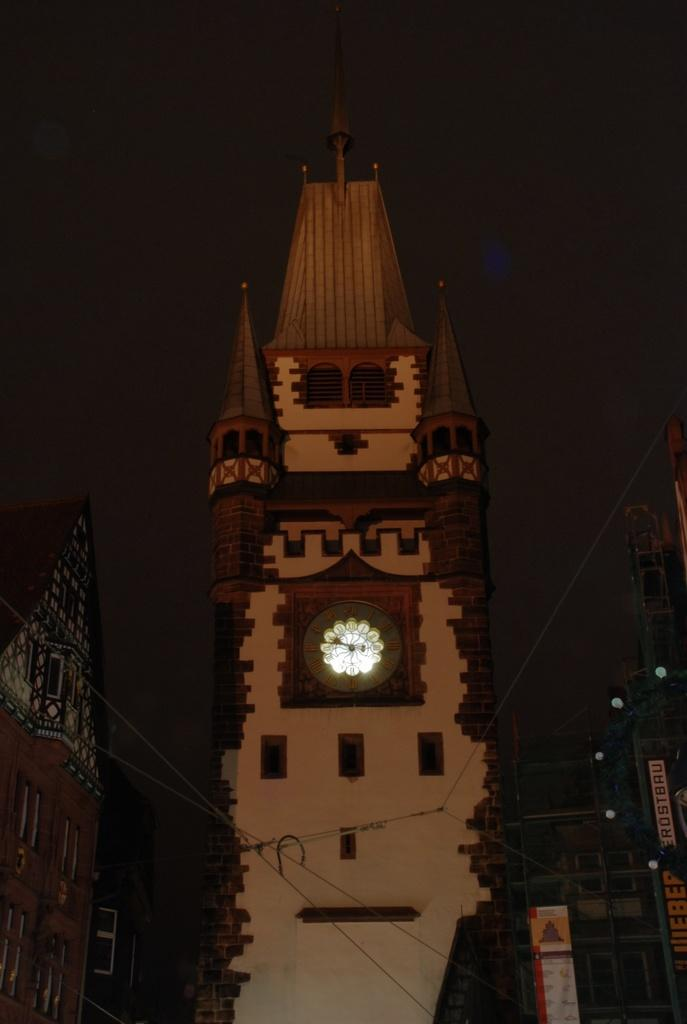What is the main structure in the front of the image? There is a tall clock tower in the front of the image. What other structures are present near the clock tower? There are buildings beside the clock tower. How would you describe the overall lighting in the image? The background of the image is dark. What type of stew is being cooked in the clock tower? There is no indication of any cooking or stew in the image, as it primarily features a clock tower and surrounding buildings. 